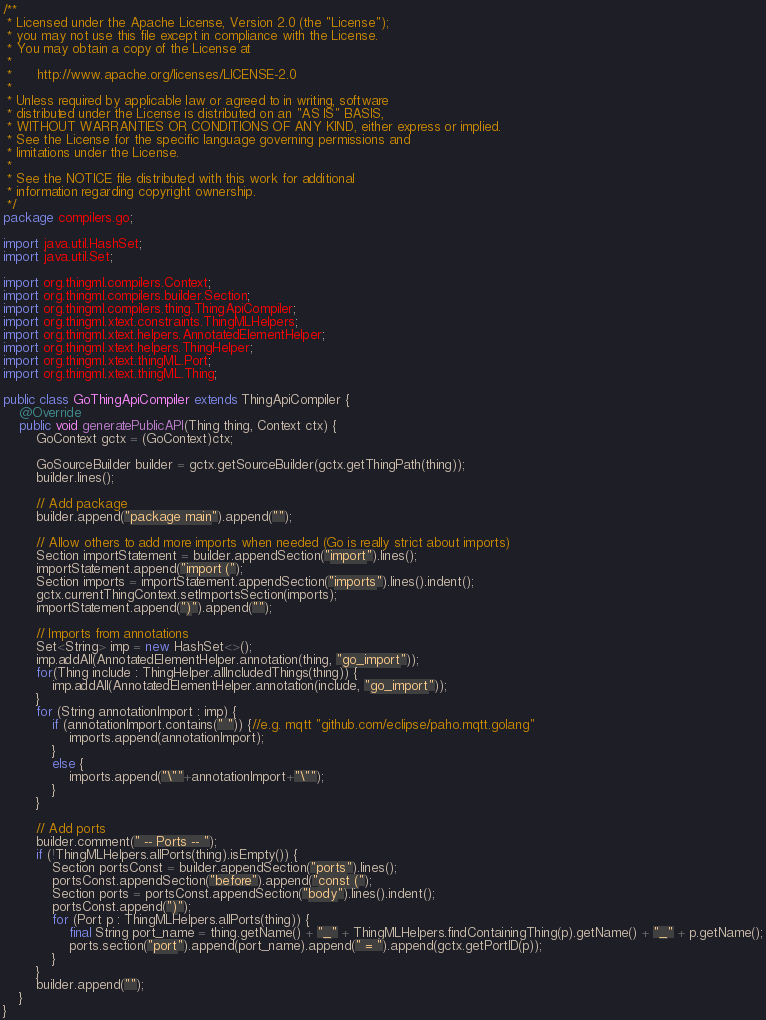<code> <loc_0><loc_0><loc_500><loc_500><_Java_>/**
 * Licensed under the Apache License, Version 2.0 (the "License");
 * you may not use this file except in compliance with the License.
 * You may obtain a copy of the License at
 *
 *      http://www.apache.org/licenses/LICENSE-2.0
 *
 * Unless required by applicable law or agreed to in writing, software
 * distributed under the License is distributed on an "AS IS" BASIS,
 * WITHOUT WARRANTIES OR CONDITIONS OF ANY KIND, either express or implied.
 * See the License for the specific language governing permissions and
 * limitations under the License.
 *
 * See the NOTICE file distributed with this work for additional
 * information regarding copyright ownership.
 */
package compilers.go;

import java.util.HashSet;
import java.util.Set;

import org.thingml.compilers.Context;
import org.thingml.compilers.builder.Section;
import org.thingml.compilers.thing.ThingApiCompiler;
import org.thingml.xtext.constraints.ThingMLHelpers;
import org.thingml.xtext.helpers.AnnotatedElementHelper;
import org.thingml.xtext.helpers.ThingHelper;
import org.thingml.xtext.thingML.Port;
import org.thingml.xtext.thingML.Thing;

public class GoThingApiCompiler extends ThingApiCompiler {
	@Override
	public void generatePublicAPI(Thing thing, Context ctx) {
		GoContext gctx = (GoContext)ctx;
		
		GoSourceBuilder builder = gctx.getSourceBuilder(gctx.getThingPath(thing));
		builder.lines();
		
		// Add package
		builder.append("package main").append("");
		
		// Allow others to add more imports when needed (Go is really strict about imports)
		Section importStatement = builder.appendSection("import").lines();
		importStatement.append("import (");
		Section imports = importStatement.appendSection("imports").lines().indent();
		gctx.currentThingContext.setImportsSection(imports);
		importStatement.append(")").append("");
		
		// Imports from annotations
		Set<String> imp = new HashSet<>();
		imp.addAll(AnnotatedElementHelper.annotation(thing, "go_import"));
		for(Thing include : ThingHelper.allIncludedThings(thing)) {
			imp.addAll(AnnotatedElementHelper.annotation(include, "go_import"));
		}
		for (String annotationImport : imp) {
			if (annotationImport.contains(" ")) {//e.g. mqtt "github.com/eclipse/paho.mqtt.golang"
				imports.append(annotationImport);
			}
			else {
				imports.append("\""+annotationImport+"\"");
			}
		}
		
		// Add ports
		builder.comment(" -- Ports -- ");
		if (!ThingMLHelpers.allPorts(thing).isEmpty()) {
			Section portsConst = builder.appendSection("ports").lines();
			portsConst.appendSection("before").append("const (");
			Section ports = portsConst.appendSection("body").lines().indent();
			portsConst.append(")");
			for (Port p : ThingMLHelpers.allPorts(thing)) {
				final String port_name = thing.getName() + "_" + ThingMLHelpers.findContainingThing(p).getName() + "_" + p.getName();
				ports.section("port").append(port_name).append(" = ").append(gctx.getPortID(p));
			}
		}
		builder.append("");
	}
}
</code> 